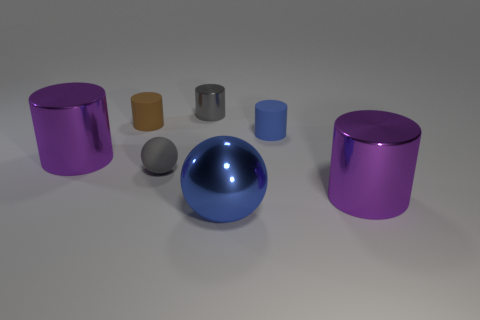There is another rubber thing that is the same shape as the brown object; what is its size?
Offer a very short reply. Small. Do the gray metal object and the blue shiny thing have the same shape?
Provide a short and direct response. No. There is a blue metallic thing to the right of the purple shiny cylinder that is to the left of the tiny shiny thing; what is its size?
Provide a short and direct response. Large. There is a tiny matte thing that is the same shape as the large blue thing; what is its color?
Your answer should be very brief. Gray. What number of small things have the same color as the big sphere?
Provide a short and direct response. 1. What size is the brown cylinder?
Provide a short and direct response. Small. Is the gray sphere the same size as the brown thing?
Your answer should be very brief. Yes. What color is the large object that is both to the right of the gray ball and to the left of the small blue cylinder?
Your answer should be very brief. Blue. What number of big purple objects are made of the same material as the big blue ball?
Provide a short and direct response. 2. How many big shiny cylinders are there?
Offer a very short reply. 2. 